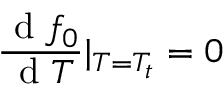<formula> <loc_0><loc_0><loc_500><loc_500>\frac { d f _ { 0 } } { d T } | _ { T = T _ { t } } = 0</formula> 